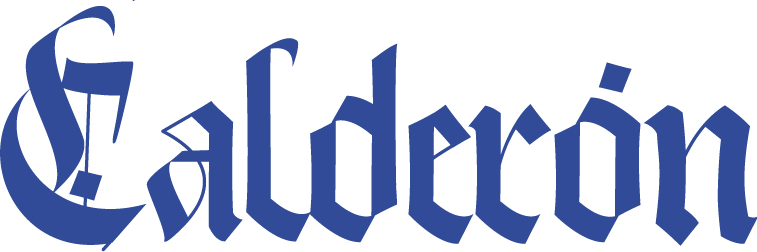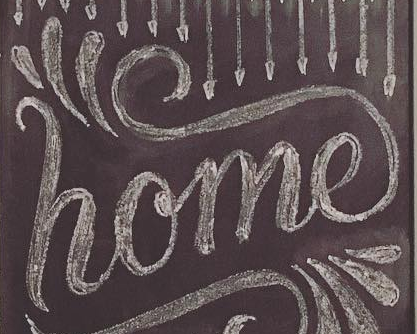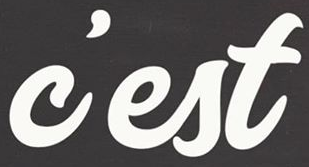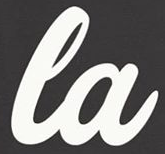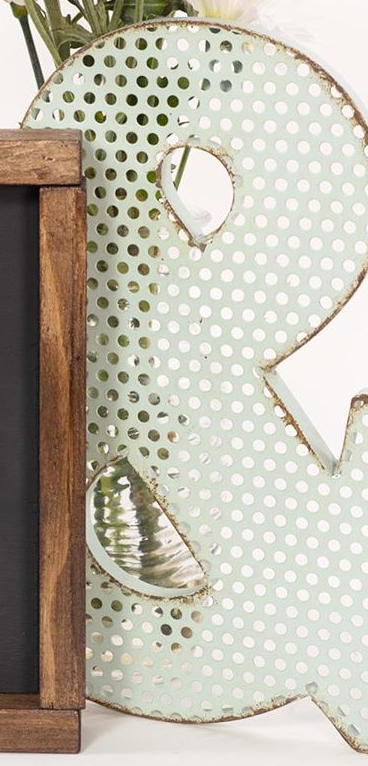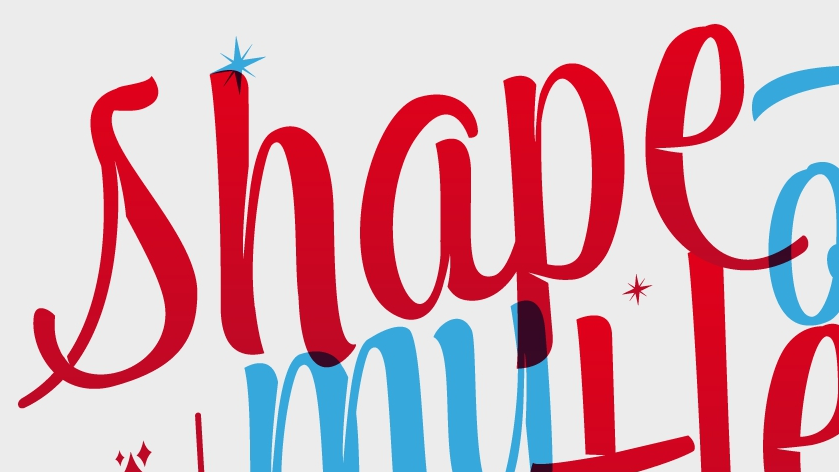Read the text content from these images in order, separated by a semicolon. Calderón; home; c'est; la; &; shape 